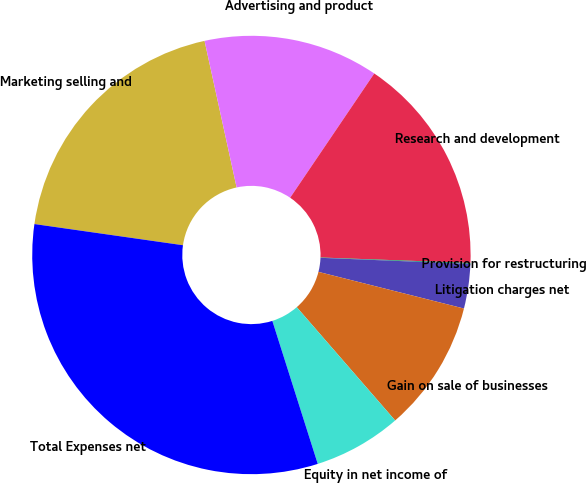Convert chart to OTSL. <chart><loc_0><loc_0><loc_500><loc_500><pie_chart><fcel>Marketing selling and<fcel>Advertising and product<fcel>Research and development<fcel>Provision for restructuring<fcel>Litigation charges net<fcel>Gain on sale of businesses<fcel>Equity in net income of<fcel>Total Expenses net<nl><fcel>19.32%<fcel>12.9%<fcel>16.11%<fcel>0.07%<fcel>3.28%<fcel>9.69%<fcel>6.49%<fcel>32.15%<nl></chart> 